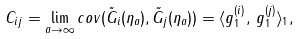Convert formula to latex. <formula><loc_0><loc_0><loc_500><loc_500>C _ { i j } = \lim _ { a \rightarrow \infty } c o v ( \tilde { G } _ { i } ( \eta _ { a } ) , \tilde { G } _ { j } ( \eta _ { a } ) ) = \langle g _ { 1 } ^ { ( i ) } , \, g _ { 1 } ^ { ( j ) } \rangle _ { 1 } ,</formula> 